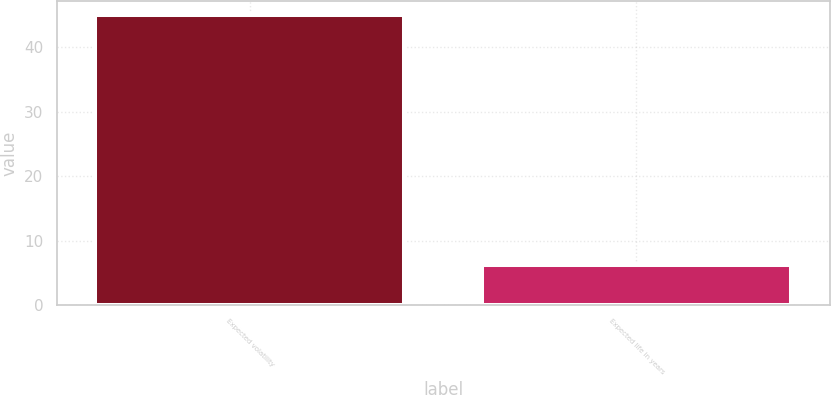<chart> <loc_0><loc_0><loc_500><loc_500><bar_chart><fcel>Expected volatility<fcel>Expected life in years<nl><fcel>45<fcel>6.25<nl></chart> 